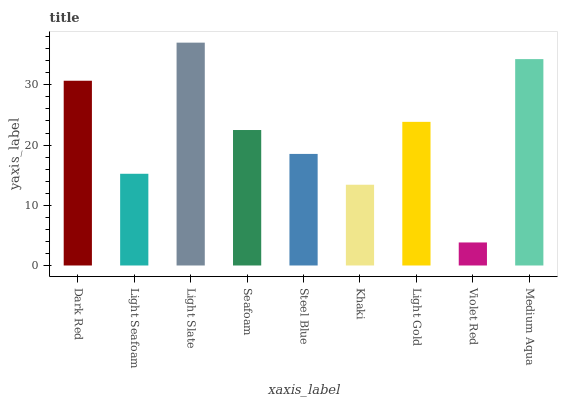Is Violet Red the minimum?
Answer yes or no. Yes. Is Light Slate the maximum?
Answer yes or no. Yes. Is Light Seafoam the minimum?
Answer yes or no. No. Is Light Seafoam the maximum?
Answer yes or no. No. Is Dark Red greater than Light Seafoam?
Answer yes or no. Yes. Is Light Seafoam less than Dark Red?
Answer yes or no. Yes. Is Light Seafoam greater than Dark Red?
Answer yes or no. No. Is Dark Red less than Light Seafoam?
Answer yes or no. No. Is Seafoam the high median?
Answer yes or no. Yes. Is Seafoam the low median?
Answer yes or no. Yes. Is Violet Red the high median?
Answer yes or no. No. Is Violet Red the low median?
Answer yes or no. No. 